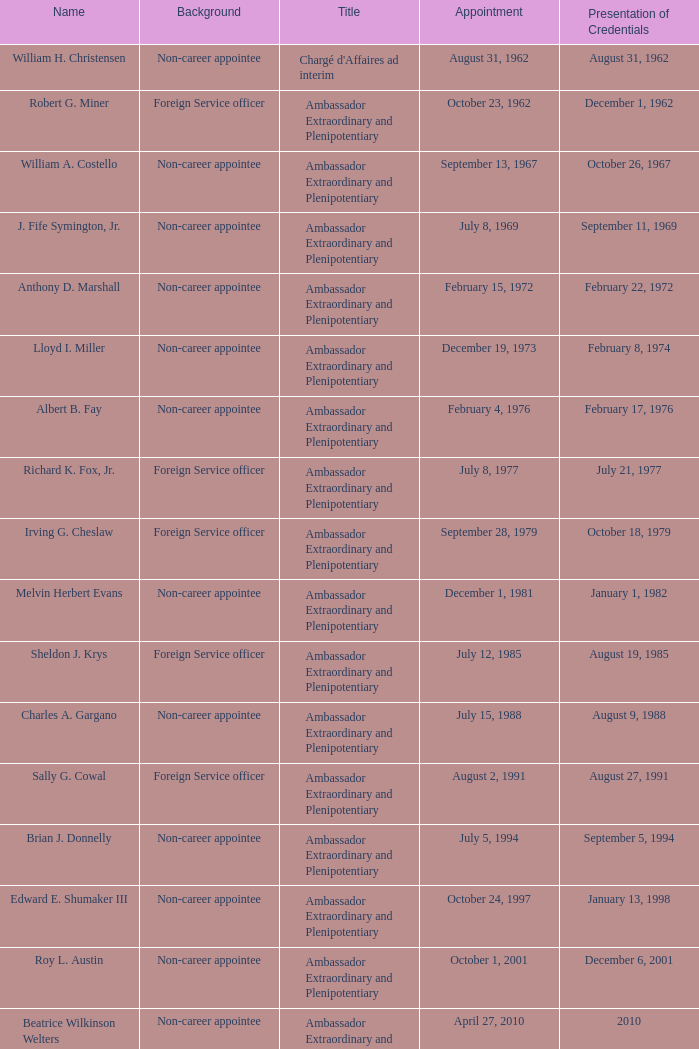Who was appointed on October 24, 1997? Edward E. Shumaker III. 